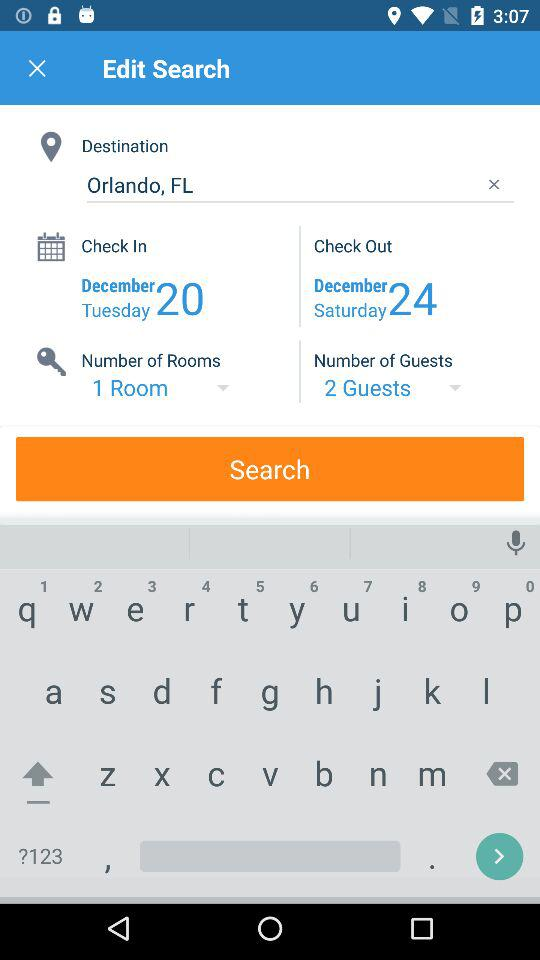How many more guests are there than rooms?
Answer the question using a single word or phrase. 1 